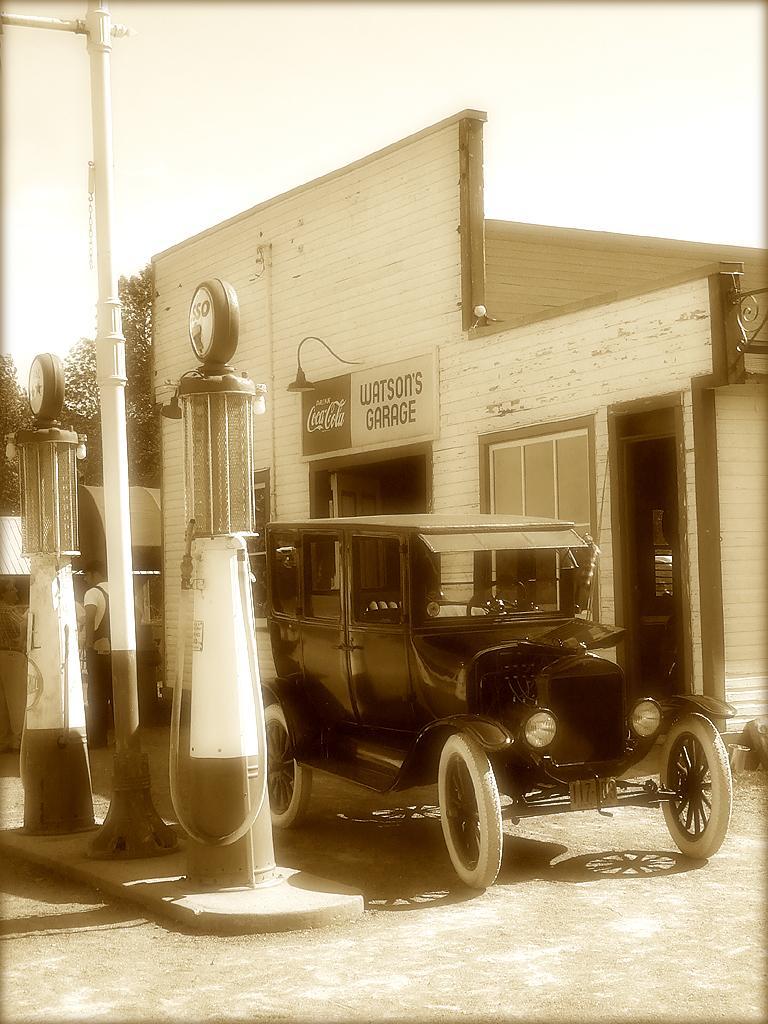Could you give a brief overview of what you see in this image? In this image we can see store, hoarding, light, poles, vehicle, person, sky, trees and things. 